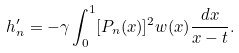<formula> <loc_0><loc_0><loc_500><loc_500>h _ { n } ^ { \prime } = - \gamma \int _ { 0 } ^ { 1 } [ P _ { n } ( x ) ] ^ { 2 } w ( x ) \frac { d x } { x - t } .</formula> 